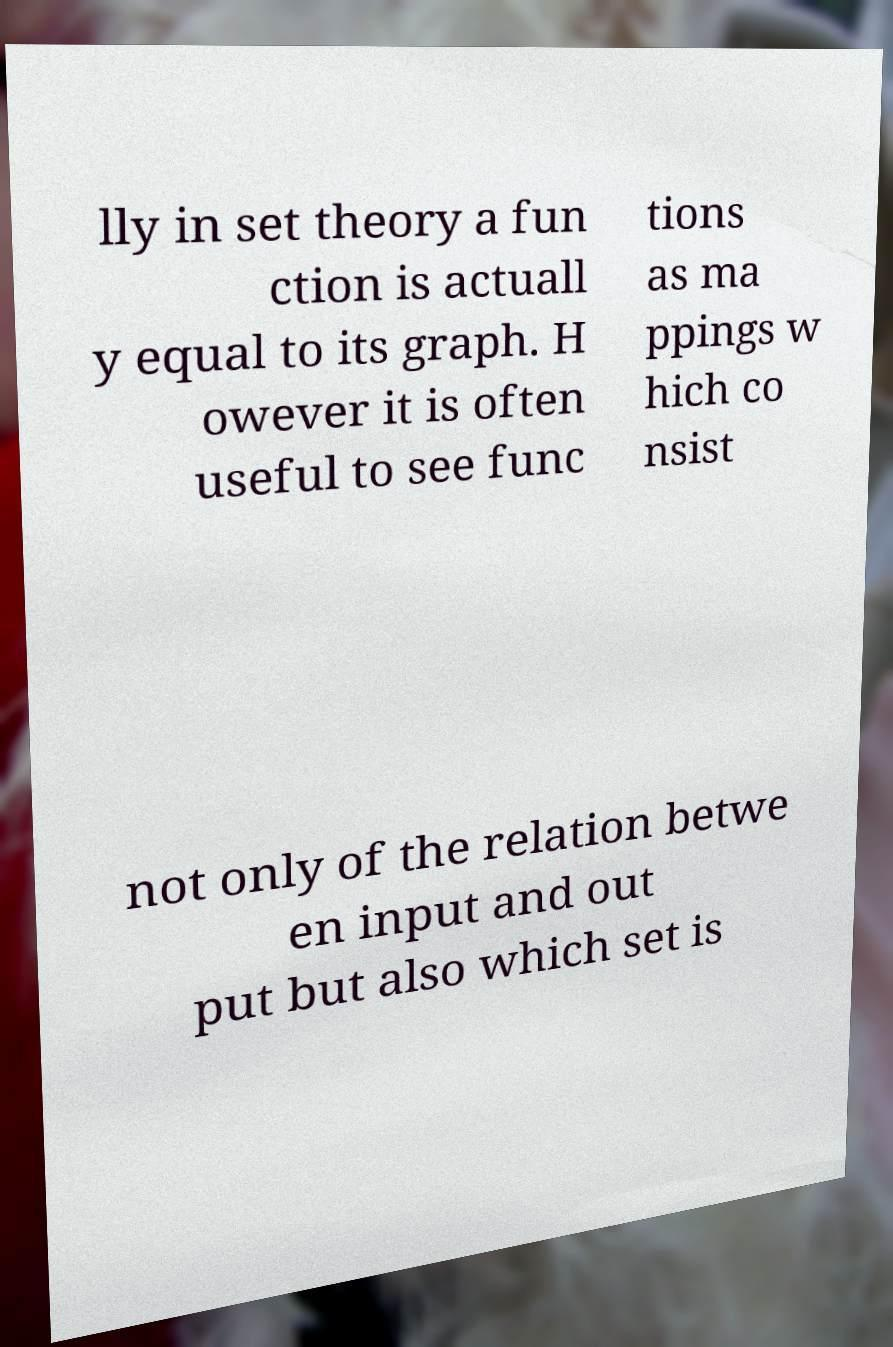For documentation purposes, I need the text within this image transcribed. Could you provide that? lly in set theory a fun ction is actuall y equal to its graph. H owever it is often useful to see func tions as ma ppings w hich co nsist not only of the relation betwe en input and out put but also which set is 